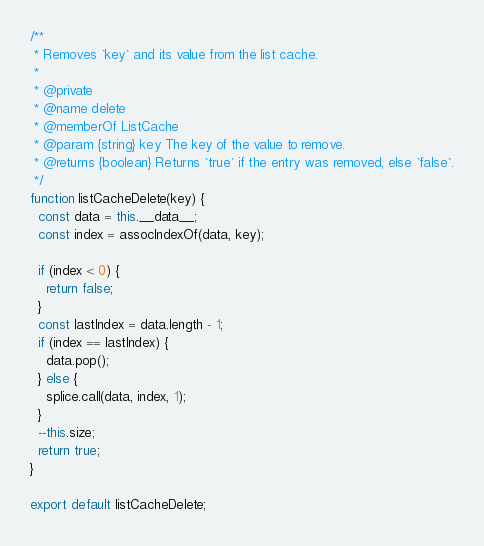Convert code to text. <code><loc_0><loc_0><loc_500><loc_500><_JavaScript_>
/**
 * Removes `key` and its value from the list cache.
 *
 * @private
 * @name delete
 * @memberOf ListCache
 * @param {string} key The key of the value to remove.
 * @returns {boolean} Returns `true` if the entry was removed, else `false`.
 */
function listCacheDelete(key) {
  const data = this.__data__;
  const index = assocIndexOf(data, key);

  if (index < 0) {
    return false;
  }
  const lastIndex = data.length - 1;
  if (index == lastIndex) {
    data.pop();
  } else {
    splice.call(data, index, 1);
  }
  --this.size;
  return true;
}

export default listCacheDelete;
</code> 